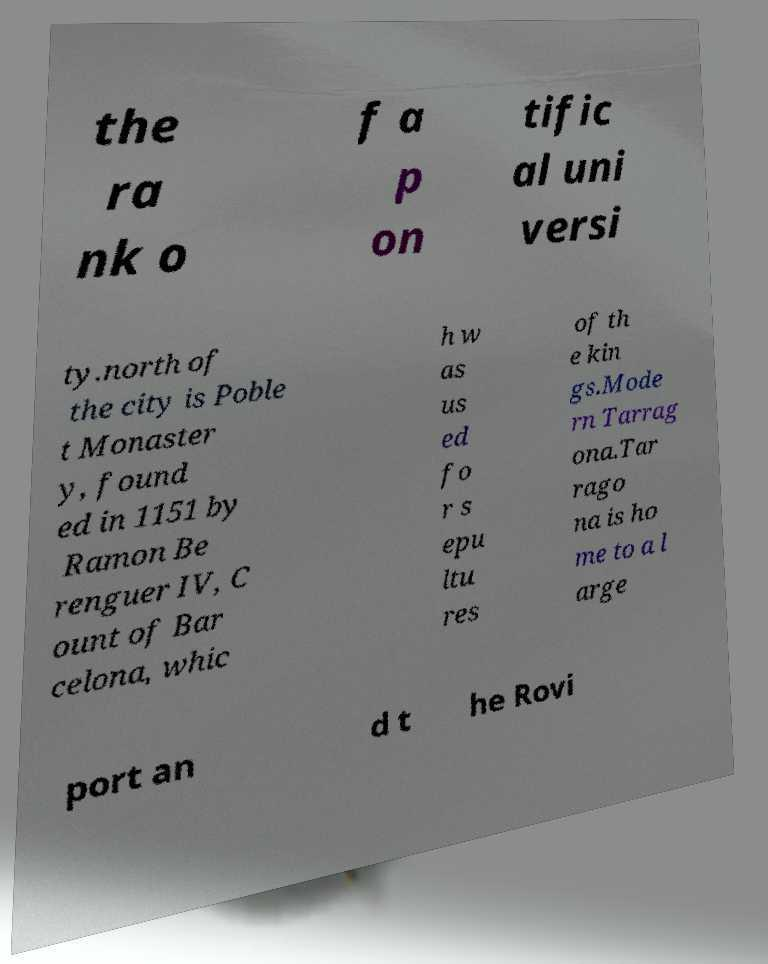Can you read and provide the text displayed in the image?This photo seems to have some interesting text. Can you extract and type it out for me? the ra nk o f a p on tific al uni versi ty.north of the city is Poble t Monaster y, found ed in 1151 by Ramon Be renguer IV, C ount of Bar celona, whic h w as us ed fo r s epu ltu res of th e kin gs.Mode rn Tarrag ona.Tar rago na is ho me to a l arge port an d t he Rovi 